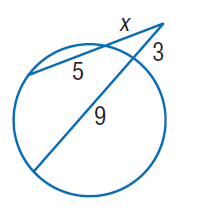Question: Find x. Round to the nearest tenth if necessary. Assume that segments that appear to be tangent are tangent.
Choices:
A. 3
B. 4
C. 5
D. 9
Answer with the letter. Answer: B 